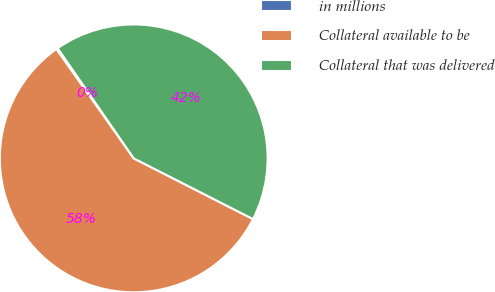<chart> <loc_0><loc_0><loc_500><loc_500><pie_chart><fcel>in millions<fcel>Collateral available to be<fcel>Collateral that was delivered<nl><fcel>0.19%<fcel>57.7%<fcel>42.11%<nl></chart> 